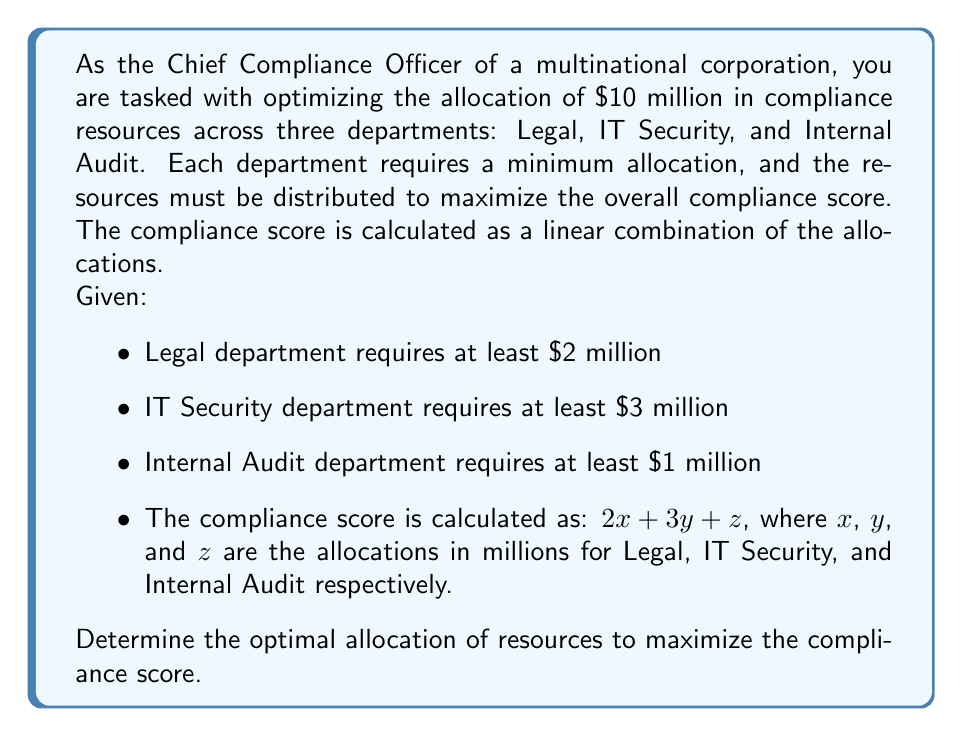Give your solution to this math problem. To solve this problem, we'll use a system of linear equations and the simplex method for linear programming. Here's the step-by-step approach:

1. Define the objective function:
   Maximize $f(x, y, z) = 2x + 3y + z$

2. Set up the constraints:
   $$\begin{aligned}
   x + y + z &= 10 \quad \text{(total budget constraint)} \\
   x &\geq 2 \quad \text{(Legal minimum)} \\
   y &\geq 3 \quad \text{(IT Security minimum)} \\
   z &\geq 1 \quad \text{(Internal Audit minimum)} \\
   x, y, z &\geq 0 \quad \text{(non-negativity constraints)}
   \end{aligned}$$

3. Convert to standard form by introducing slack variables:
   $$\begin{aligned}
   x + y + z + s_1 &= 10 \\
   x - s_2 &= 2 \\
   y - s_3 &= 3 \\
   z - s_4 &= 1 \\
   x, y, z, s_1, s_2, s_3, s_4 &\geq 0
   \end{aligned}$$

4. Set up the initial tableau:
   $$\begin{array}{c|cccc|cccc|c}
   & x & y & z & s_1 & s_2 & s_3 & s_4 & \text{RHS} \\
   \hline
   s_1 & 1 & 1 & 1 & 1 & 0 & 0 & 0 & 10 \\
   x & 1 & 0 & 0 & 0 & -1 & 0 & 0 & 2 \\
   y & 0 & 1 & 0 & 0 & 0 & -1 & 0 & 3 \\
   z & 0 & 0 & 1 & 0 & 0 & 0 & -1 & 1 \\
   \hline
   -f & -2 & -3 & -1 & 0 & 0 & 0 & 0 & 0
   \end{array}$$

5. Apply the simplex method:
   - The most negative coefficient in the objective row is -3, corresponding to y.
   - The limiting ratio is 10/1 = 10 for the first row.
   - Pivot on the element (1,2) to get the new tableau.

6. After pivoting, we get:
   $$\begin{array}{c|cccc|cccc|c}
   & x & y & z & s_1 & s_2 & s_3 & s_4 & \text{RHS} \\
   \hline
   y & 1 & 1 & 1 & 1 & 0 & 0 & 0 & 10 \\
   x & 1 & 0 & 0 & 0 & -1 & 0 & 0 & 2 \\
   s_3 & -1 & 0 & -1 & -1 & 0 & 1 & 0 & -7 \\
   z & 0 & 0 & 1 & 0 & 0 & 0 & -1 & 1 \\
   \hline
   -f & 1 & 0 & 2 & 3 & 0 & 3 & 0 & 30
   \end{array}$$

7. The optimal solution is reached as there are no negative coefficients in the objective row.

8. Read the solution from the tableau:
   $x = 2$, $y = 10$, $z = 1$

9. Calculate the maximum compliance score:
   $f(2, 10, 1) = 2(2) + 3(10) + 1 = 35$
Answer: The optimal allocation of resources is:
Legal (x): $2 million
IT Security (y): $7 million
Internal Audit (z): $1 million

The maximum compliance score achievable is 35. 